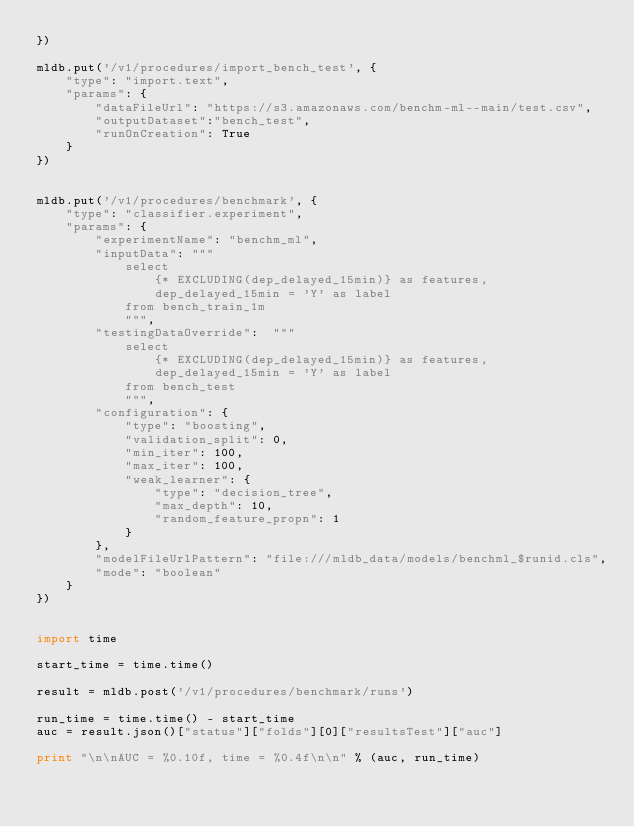Convert code to text. <code><loc_0><loc_0><loc_500><loc_500><_Python_>})

mldb.put('/v1/procedures/import_bench_test', {
    "type": "import.text",
    "params": { 
        "dataFileUrl": "https://s3.amazonaws.com/benchm-ml--main/test.csv",
        "outputDataset":"bench_test",
        "runOnCreation": True
    }
})


mldb.put('/v1/procedures/benchmark', {
    "type": "classifier.experiment",
    "params": {
        "experimentName": "benchm_ml",
        "inputData": """
            select
                {* EXCLUDING(dep_delayed_15min)} as features,
                dep_delayed_15min = 'Y' as label
            from bench_train_1m
            """,
        "testingDataOverride":  """
            select
                {* EXCLUDING(dep_delayed_15min)} as features,
                dep_delayed_15min = 'Y' as label
            from bench_test
            """,
        "configuration": {
            "type": "boosting",
            "validation_split": 0,
            "min_iter": 100,
            "max_iter": 100,
            "weak_learner": {
                "type": "decision_tree",
                "max_depth": 10,
                "random_feature_propn": 1
            }
        },
        "modelFileUrlPattern": "file:///mldb_data/models/benchml_$runid.cls",       
        "mode": "boolean"
    }
})


import time

start_time = time.time()

result = mldb.post('/v1/procedures/benchmark/runs')

run_time = time.time() - start_time
auc = result.json()["status"]["folds"][0]["resultsTest"]["auc"]

print "\n\nAUC = %0.10f, time = %0.4f\n\n" % (auc, run_time)


</code> 